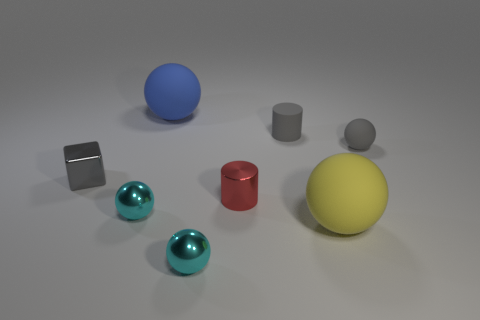How many cyan balls must be subtracted to get 1 cyan balls? 1 Subtract all big yellow rubber balls. How many balls are left? 4 Subtract all purple blocks. How many cyan spheres are left? 2 Subtract all cyan spheres. How many spheres are left? 3 Add 2 yellow cubes. How many objects exist? 10 Subtract all green spheres. Subtract all blue cylinders. How many spheres are left? 5 Subtract all balls. How many objects are left? 3 Add 4 tiny brown cylinders. How many tiny brown cylinders exist? 4 Subtract 0 brown spheres. How many objects are left? 8 Subtract all gray blocks. Subtract all small cubes. How many objects are left? 6 